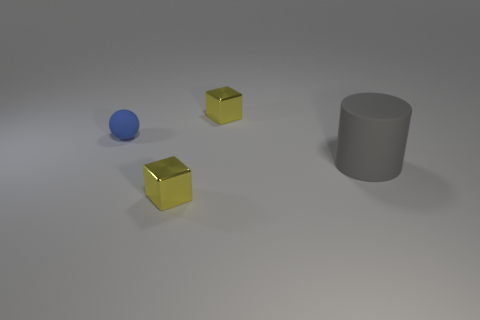Are there any spheres in front of the small matte object?
Offer a very short reply. No. Is there any other thing that has the same material as the tiny sphere?
Provide a short and direct response. Yes. How many other things are the same shape as the big object?
Keep it short and to the point. 0. What number of small yellow cubes are behind the yellow metallic block on the left side of the small metal thing behind the small blue sphere?
Provide a succinct answer. 1. How many tiny blue rubber objects have the same shape as the gray object?
Keep it short and to the point. 0. Is the color of the small metal cube behind the gray thing the same as the large thing?
Ensure brevity in your answer.  No. There is a tiny yellow shiny thing that is to the left of the yellow cube behind the small metal thing in front of the matte cylinder; what is its shape?
Make the answer very short. Cube. Is the size of the gray object the same as the shiny block that is in front of the ball?
Your answer should be very brief. No. Are there any blue things that have the same size as the rubber cylinder?
Make the answer very short. No. How many other objects are the same material as the big cylinder?
Offer a very short reply. 1. 